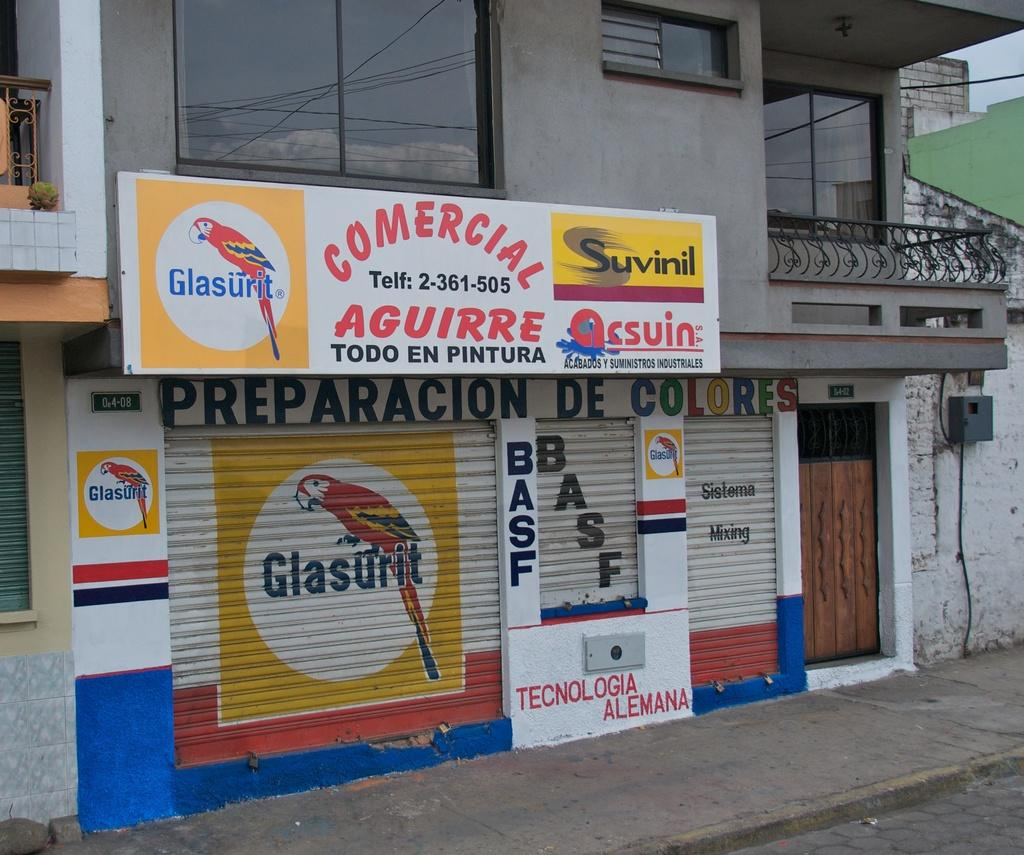What is the main structure visible in the image? There is a building in the picture. Are there any decorative elements on the building? Yes, the building has a parrot picture on the shutters. Is there any signage on the building? Yes, there is a name board on the building. What colors are used on the name board? The name board has blue, white, and yellow colors. Can you tell me how many bottles of soda are displayed on the building? There is no mention of soda bottles in the image, so it is not possible to answer that question. 